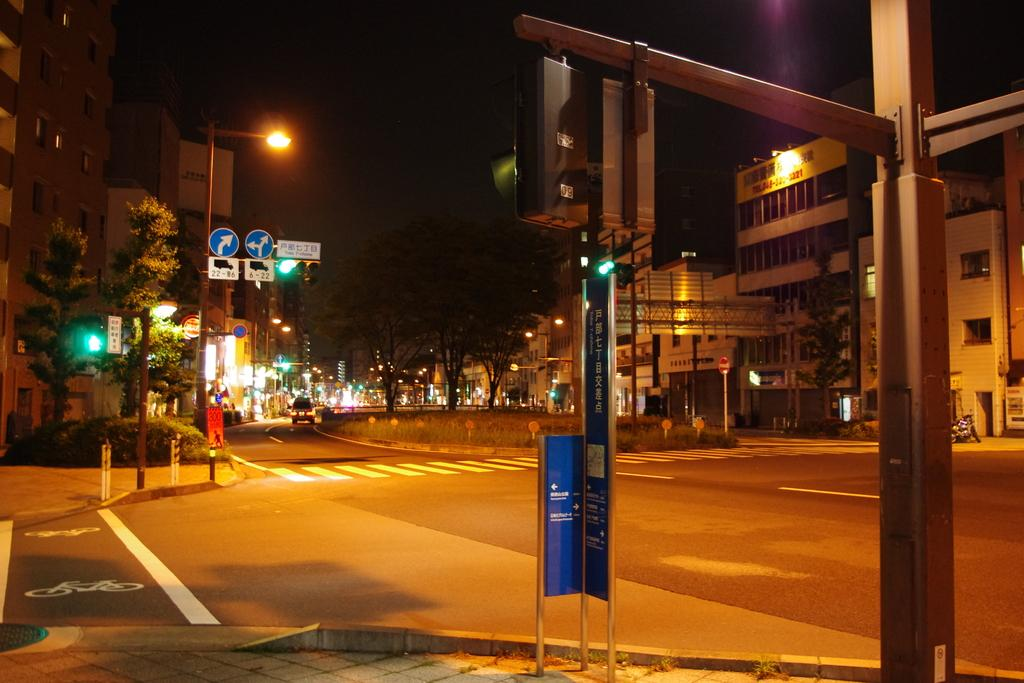What can be seen in the middle of the image? There are poles in the middle of the image. What is attached to the poles? There are sign boards on the poles. What can be seen in the background of the image? There are trees and buildings visible in the background. What is present on the road in the image? There are vehicles on the road. What type of ornament can be seen hanging from the branches of the trees in the image? There are no ornaments hanging from the branches of the trees in the image, as the trees are in the background and the focus is on the poles and sign boards. 